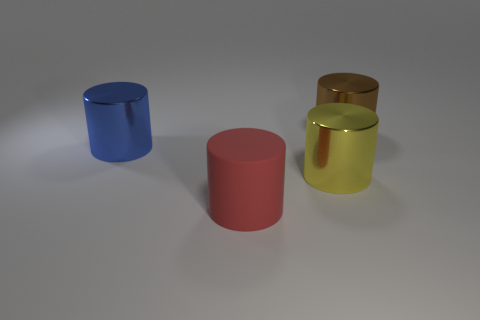Are there an equal number of yellow things that are behind the blue metal cylinder and red matte objects behind the big brown cylinder?
Provide a succinct answer. Yes. What number of things are red matte cylinders or brown metallic objects?
Provide a short and direct response. 2. How many things are objects in front of the brown cylinder or big things that are behind the yellow thing?
Offer a very short reply. 4. Is the number of brown shiny cylinders in front of the blue metal object the same as the number of large blue cylinders?
Offer a terse response. No. Is the size of the metal cylinder behind the blue thing the same as the metallic thing on the left side of the red cylinder?
Ensure brevity in your answer.  Yes. What number of other objects are the same size as the blue metal object?
Provide a short and direct response. 3. There is a shiny cylinder that is behind the cylinder on the left side of the red rubber thing; is there a red cylinder that is on the right side of it?
Your answer should be compact. No. Are there any other things of the same color as the rubber thing?
Make the answer very short. No. There is a shiny cylinder to the left of the red cylinder; what is its size?
Offer a terse response. Large. What is the size of the cylinder behind the large metallic cylinder that is to the left of the metal cylinder in front of the big blue cylinder?
Make the answer very short. Large. 